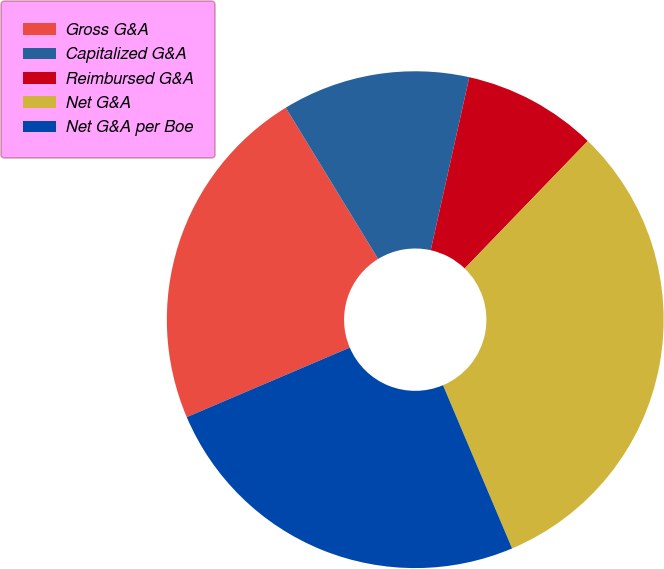Convert chart to OTSL. <chart><loc_0><loc_0><loc_500><loc_500><pie_chart><fcel>Gross G&A<fcel>Capitalized G&A<fcel>Reimbursed G&A<fcel>Net G&A<fcel>Net G&A per Boe<nl><fcel>22.69%<fcel>12.22%<fcel>8.73%<fcel>31.41%<fcel>24.96%<nl></chart> 